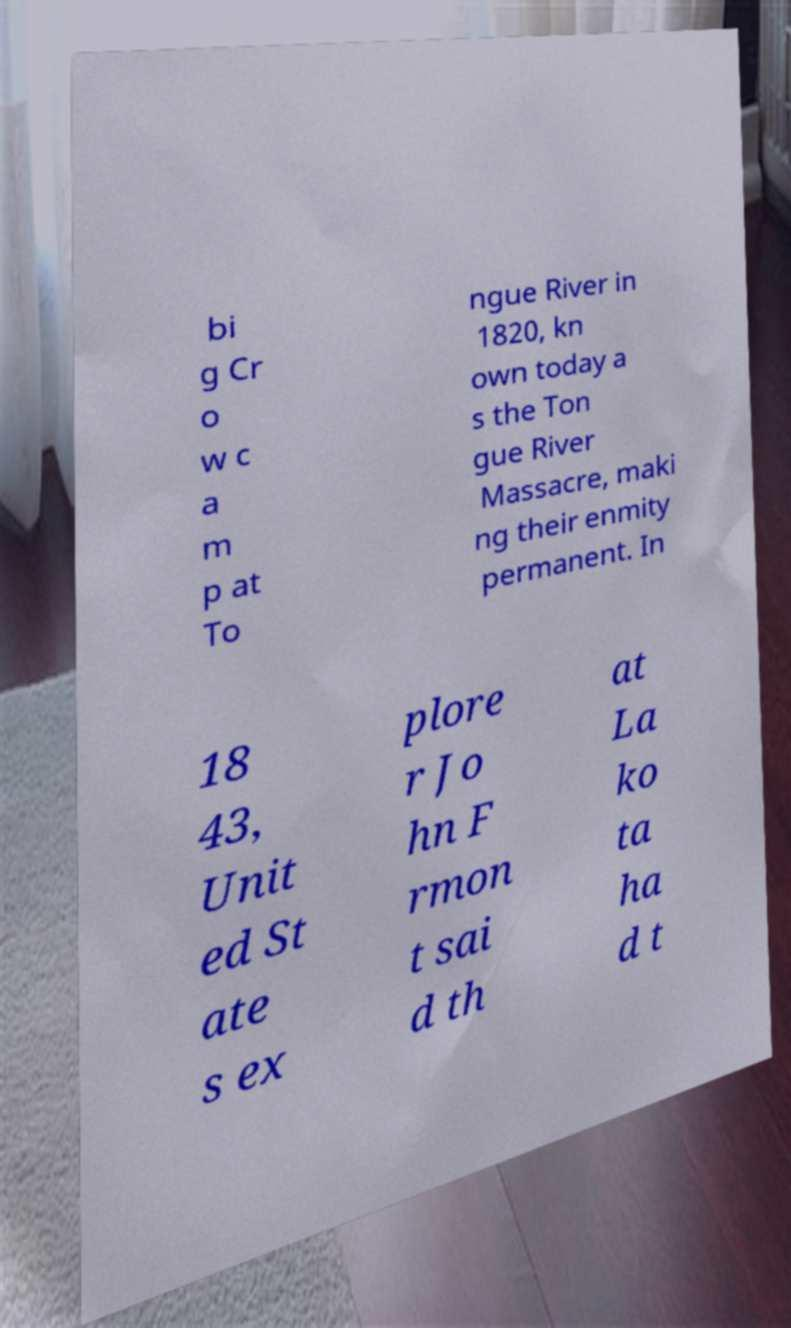For documentation purposes, I need the text within this image transcribed. Could you provide that? bi g Cr o w c a m p at To ngue River in 1820, kn own today a s the Ton gue River Massacre, maki ng their enmity permanent. In 18 43, Unit ed St ate s ex plore r Jo hn F rmon t sai d th at La ko ta ha d t 